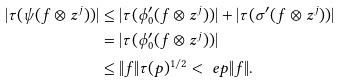Convert formula to latex. <formula><loc_0><loc_0><loc_500><loc_500>| \tau ( \psi ( f \otimes z ^ { j } ) ) | & \leq | \tau ( \phi _ { 0 } ^ { \prime } ( f \otimes z ^ { j } ) ) | + | \tau ( \sigma ^ { \prime } ( f \otimes z ^ { j } ) ) | \\ & = | \tau ( \phi _ { 0 } ^ { \prime } ( f \otimes z ^ { j } ) ) | \\ & \leq \| f \| \tau ( p ) ^ { 1 / 2 } < \ e p \| f \| .</formula> 